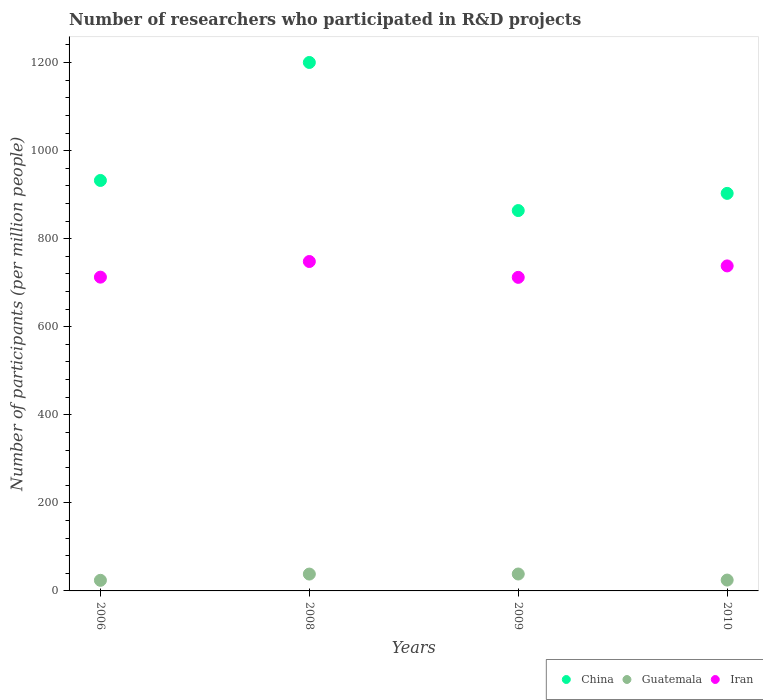How many different coloured dotlines are there?
Provide a succinct answer. 3. Is the number of dotlines equal to the number of legend labels?
Provide a short and direct response. Yes. What is the number of researchers who participated in R&D projects in Guatemala in 2009?
Keep it short and to the point. 38.42. Across all years, what is the maximum number of researchers who participated in R&D projects in Guatemala?
Offer a very short reply. 38.42. Across all years, what is the minimum number of researchers who participated in R&D projects in Iran?
Provide a succinct answer. 712.22. In which year was the number of researchers who participated in R&D projects in Guatemala minimum?
Offer a terse response. 2006. What is the total number of researchers who participated in R&D projects in Iran in the graph?
Your response must be concise. 2911.3. What is the difference between the number of researchers who participated in R&D projects in Guatemala in 2008 and that in 2010?
Offer a terse response. 13.64. What is the difference between the number of researchers who participated in R&D projects in China in 2006 and the number of researchers who participated in R&D projects in Iran in 2008?
Ensure brevity in your answer.  184.11. What is the average number of researchers who participated in R&D projects in China per year?
Provide a short and direct response. 974.87. In the year 2008, what is the difference between the number of researchers who participated in R&D projects in Iran and number of researchers who participated in R&D projects in Guatemala?
Give a very brief answer. 709.93. In how many years, is the number of researchers who participated in R&D projects in Guatemala greater than 720?
Provide a short and direct response. 0. What is the ratio of the number of researchers who participated in R&D projects in China in 2008 to that in 2010?
Offer a terse response. 1.33. Is the number of researchers who participated in R&D projects in China in 2006 less than that in 2010?
Your answer should be compact. No. Is the difference between the number of researchers who participated in R&D projects in Iran in 2006 and 2009 greater than the difference between the number of researchers who participated in R&D projects in Guatemala in 2006 and 2009?
Provide a short and direct response. Yes. What is the difference between the highest and the second highest number of researchers who participated in R&D projects in Iran?
Make the answer very short. 10.02. What is the difference between the highest and the lowest number of researchers who participated in R&D projects in China?
Ensure brevity in your answer.  336.37. Does the number of researchers who participated in R&D projects in Guatemala monotonically increase over the years?
Your answer should be very brief. No. Is the number of researchers who participated in R&D projects in Iran strictly greater than the number of researchers who participated in R&D projects in Guatemala over the years?
Your answer should be compact. Yes. Is the number of researchers who participated in R&D projects in Iran strictly less than the number of researchers who participated in R&D projects in Guatemala over the years?
Your answer should be compact. No. How many dotlines are there?
Your answer should be very brief. 3. Does the graph contain any zero values?
Your answer should be compact. No. Does the graph contain grids?
Your response must be concise. No. How many legend labels are there?
Provide a short and direct response. 3. How are the legend labels stacked?
Offer a terse response. Horizontal. What is the title of the graph?
Give a very brief answer. Number of researchers who participated in R&D projects. What is the label or title of the Y-axis?
Ensure brevity in your answer.  Number of participants (per million people). What is the Number of participants (per million people) of China in 2006?
Your answer should be very brief. 932.31. What is the Number of participants (per million people) in Guatemala in 2006?
Ensure brevity in your answer.  24.09. What is the Number of participants (per million people) in Iran in 2006?
Provide a succinct answer. 712.69. What is the Number of participants (per million people) in China in 2008?
Your answer should be compact. 1200.29. What is the Number of participants (per million people) of Guatemala in 2008?
Your response must be concise. 38.28. What is the Number of participants (per million people) of Iran in 2008?
Offer a terse response. 748.21. What is the Number of participants (per million people) of China in 2009?
Offer a very short reply. 863.93. What is the Number of participants (per million people) in Guatemala in 2009?
Your response must be concise. 38.42. What is the Number of participants (per million people) of Iran in 2009?
Offer a terse response. 712.22. What is the Number of participants (per million people) of China in 2010?
Provide a short and direct response. 902.96. What is the Number of participants (per million people) of Guatemala in 2010?
Ensure brevity in your answer.  24.64. What is the Number of participants (per million people) in Iran in 2010?
Keep it short and to the point. 738.19. Across all years, what is the maximum Number of participants (per million people) of China?
Make the answer very short. 1200.29. Across all years, what is the maximum Number of participants (per million people) in Guatemala?
Make the answer very short. 38.42. Across all years, what is the maximum Number of participants (per million people) in Iran?
Give a very brief answer. 748.21. Across all years, what is the minimum Number of participants (per million people) of China?
Give a very brief answer. 863.93. Across all years, what is the minimum Number of participants (per million people) of Guatemala?
Keep it short and to the point. 24.09. Across all years, what is the minimum Number of participants (per million people) in Iran?
Provide a short and direct response. 712.22. What is the total Number of participants (per million people) in China in the graph?
Your answer should be compact. 3899.5. What is the total Number of participants (per million people) in Guatemala in the graph?
Your response must be concise. 125.44. What is the total Number of participants (per million people) in Iran in the graph?
Offer a terse response. 2911.3. What is the difference between the Number of participants (per million people) of China in 2006 and that in 2008?
Your answer should be very brief. -267.98. What is the difference between the Number of participants (per million people) in Guatemala in 2006 and that in 2008?
Offer a very short reply. -14.19. What is the difference between the Number of participants (per million people) of Iran in 2006 and that in 2008?
Your answer should be very brief. -35.52. What is the difference between the Number of participants (per million people) in China in 2006 and that in 2009?
Your answer should be compact. 68.39. What is the difference between the Number of participants (per million people) of Guatemala in 2006 and that in 2009?
Make the answer very short. -14.33. What is the difference between the Number of participants (per million people) in Iran in 2006 and that in 2009?
Your answer should be very brief. 0.47. What is the difference between the Number of participants (per million people) of China in 2006 and that in 2010?
Provide a succinct answer. 29.35. What is the difference between the Number of participants (per million people) in Guatemala in 2006 and that in 2010?
Ensure brevity in your answer.  -0.55. What is the difference between the Number of participants (per million people) in Iran in 2006 and that in 2010?
Keep it short and to the point. -25.5. What is the difference between the Number of participants (per million people) of China in 2008 and that in 2009?
Make the answer very short. 336.37. What is the difference between the Number of participants (per million people) in Guatemala in 2008 and that in 2009?
Your answer should be compact. -0.14. What is the difference between the Number of participants (per million people) of Iran in 2008 and that in 2009?
Make the answer very short. 35.99. What is the difference between the Number of participants (per million people) in China in 2008 and that in 2010?
Offer a very short reply. 297.34. What is the difference between the Number of participants (per million people) in Guatemala in 2008 and that in 2010?
Give a very brief answer. 13.64. What is the difference between the Number of participants (per million people) of Iran in 2008 and that in 2010?
Offer a terse response. 10.02. What is the difference between the Number of participants (per million people) in China in 2009 and that in 2010?
Your answer should be compact. -39.03. What is the difference between the Number of participants (per million people) of Guatemala in 2009 and that in 2010?
Offer a very short reply. 13.78. What is the difference between the Number of participants (per million people) in Iran in 2009 and that in 2010?
Provide a short and direct response. -25.97. What is the difference between the Number of participants (per million people) in China in 2006 and the Number of participants (per million people) in Guatemala in 2008?
Your answer should be very brief. 894.03. What is the difference between the Number of participants (per million people) in China in 2006 and the Number of participants (per million people) in Iran in 2008?
Provide a short and direct response. 184.11. What is the difference between the Number of participants (per million people) in Guatemala in 2006 and the Number of participants (per million people) in Iran in 2008?
Give a very brief answer. -724.12. What is the difference between the Number of participants (per million people) of China in 2006 and the Number of participants (per million people) of Guatemala in 2009?
Your answer should be very brief. 893.89. What is the difference between the Number of participants (per million people) in China in 2006 and the Number of participants (per million people) in Iran in 2009?
Your response must be concise. 220.1. What is the difference between the Number of participants (per million people) of Guatemala in 2006 and the Number of participants (per million people) of Iran in 2009?
Your answer should be compact. -688.12. What is the difference between the Number of participants (per million people) in China in 2006 and the Number of participants (per million people) in Guatemala in 2010?
Make the answer very short. 907.67. What is the difference between the Number of participants (per million people) in China in 2006 and the Number of participants (per million people) in Iran in 2010?
Provide a short and direct response. 194.13. What is the difference between the Number of participants (per million people) of Guatemala in 2006 and the Number of participants (per million people) of Iran in 2010?
Offer a terse response. -714.1. What is the difference between the Number of participants (per million people) of China in 2008 and the Number of participants (per million people) of Guatemala in 2009?
Your answer should be very brief. 1161.87. What is the difference between the Number of participants (per million people) of China in 2008 and the Number of participants (per million people) of Iran in 2009?
Make the answer very short. 488.08. What is the difference between the Number of participants (per million people) of Guatemala in 2008 and the Number of participants (per million people) of Iran in 2009?
Your answer should be compact. -673.94. What is the difference between the Number of participants (per million people) of China in 2008 and the Number of participants (per million people) of Guatemala in 2010?
Your answer should be compact. 1175.66. What is the difference between the Number of participants (per million people) in China in 2008 and the Number of participants (per million people) in Iran in 2010?
Offer a terse response. 462.11. What is the difference between the Number of participants (per million people) of Guatemala in 2008 and the Number of participants (per million people) of Iran in 2010?
Provide a succinct answer. -699.91. What is the difference between the Number of participants (per million people) in China in 2009 and the Number of participants (per million people) in Guatemala in 2010?
Offer a terse response. 839.29. What is the difference between the Number of participants (per million people) of China in 2009 and the Number of participants (per million people) of Iran in 2010?
Your answer should be compact. 125.74. What is the difference between the Number of participants (per million people) of Guatemala in 2009 and the Number of participants (per million people) of Iran in 2010?
Offer a very short reply. -699.76. What is the average Number of participants (per million people) in China per year?
Your response must be concise. 974.87. What is the average Number of participants (per million people) in Guatemala per year?
Provide a succinct answer. 31.36. What is the average Number of participants (per million people) of Iran per year?
Provide a short and direct response. 727.82. In the year 2006, what is the difference between the Number of participants (per million people) in China and Number of participants (per million people) in Guatemala?
Provide a succinct answer. 908.22. In the year 2006, what is the difference between the Number of participants (per million people) in China and Number of participants (per million people) in Iran?
Provide a succinct answer. 219.63. In the year 2006, what is the difference between the Number of participants (per million people) of Guatemala and Number of participants (per million people) of Iran?
Provide a succinct answer. -688.59. In the year 2008, what is the difference between the Number of participants (per million people) of China and Number of participants (per million people) of Guatemala?
Provide a succinct answer. 1162.02. In the year 2008, what is the difference between the Number of participants (per million people) in China and Number of participants (per million people) in Iran?
Your answer should be compact. 452.09. In the year 2008, what is the difference between the Number of participants (per million people) in Guatemala and Number of participants (per million people) in Iran?
Offer a very short reply. -709.93. In the year 2009, what is the difference between the Number of participants (per million people) of China and Number of participants (per million people) of Guatemala?
Provide a succinct answer. 825.5. In the year 2009, what is the difference between the Number of participants (per million people) of China and Number of participants (per million people) of Iran?
Ensure brevity in your answer.  151.71. In the year 2009, what is the difference between the Number of participants (per million people) of Guatemala and Number of participants (per million people) of Iran?
Offer a terse response. -673.79. In the year 2010, what is the difference between the Number of participants (per million people) of China and Number of participants (per million people) of Guatemala?
Offer a very short reply. 878.32. In the year 2010, what is the difference between the Number of participants (per million people) of China and Number of participants (per million people) of Iran?
Offer a terse response. 164.77. In the year 2010, what is the difference between the Number of participants (per million people) of Guatemala and Number of participants (per million people) of Iran?
Your response must be concise. -713.55. What is the ratio of the Number of participants (per million people) of China in 2006 to that in 2008?
Keep it short and to the point. 0.78. What is the ratio of the Number of participants (per million people) of Guatemala in 2006 to that in 2008?
Offer a terse response. 0.63. What is the ratio of the Number of participants (per million people) in Iran in 2006 to that in 2008?
Make the answer very short. 0.95. What is the ratio of the Number of participants (per million people) of China in 2006 to that in 2009?
Offer a terse response. 1.08. What is the ratio of the Number of participants (per million people) in Guatemala in 2006 to that in 2009?
Give a very brief answer. 0.63. What is the ratio of the Number of participants (per million people) of China in 2006 to that in 2010?
Offer a very short reply. 1.03. What is the ratio of the Number of participants (per million people) of Guatemala in 2006 to that in 2010?
Give a very brief answer. 0.98. What is the ratio of the Number of participants (per million people) in Iran in 2006 to that in 2010?
Offer a very short reply. 0.97. What is the ratio of the Number of participants (per million people) of China in 2008 to that in 2009?
Offer a very short reply. 1.39. What is the ratio of the Number of participants (per million people) in Guatemala in 2008 to that in 2009?
Ensure brevity in your answer.  1. What is the ratio of the Number of participants (per million people) in Iran in 2008 to that in 2009?
Ensure brevity in your answer.  1.05. What is the ratio of the Number of participants (per million people) of China in 2008 to that in 2010?
Provide a short and direct response. 1.33. What is the ratio of the Number of participants (per million people) in Guatemala in 2008 to that in 2010?
Provide a short and direct response. 1.55. What is the ratio of the Number of participants (per million people) in Iran in 2008 to that in 2010?
Keep it short and to the point. 1.01. What is the ratio of the Number of participants (per million people) in China in 2009 to that in 2010?
Keep it short and to the point. 0.96. What is the ratio of the Number of participants (per million people) in Guatemala in 2009 to that in 2010?
Your answer should be very brief. 1.56. What is the ratio of the Number of participants (per million people) in Iran in 2009 to that in 2010?
Ensure brevity in your answer.  0.96. What is the difference between the highest and the second highest Number of participants (per million people) of China?
Keep it short and to the point. 267.98. What is the difference between the highest and the second highest Number of participants (per million people) in Guatemala?
Provide a short and direct response. 0.14. What is the difference between the highest and the second highest Number of participants (per million people) of Iran?
Offer a very short reply. 10.02. What is the difference between the highest and the lowest Number of participants (per million people) in China?
Your answer should be very brief. 336.37. What is the difference between the highest and the lowest Number of participants (per million people) in Guatemala?
Your response must be concise. 14.33. What is the difference between the highest and the lowest Number of participants (per million people) of Iran?
Give a very brief answer. 35.99. 